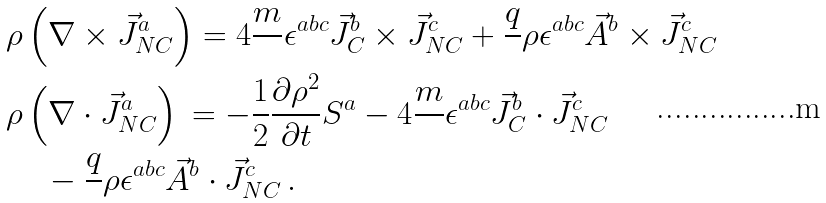<formula> <loc_0><loc_0><loc_500><loc_500>& \rho \left ( \nabla \times \vec { J } _ { N C } ^ { a } \right ) = 4 \frac { m } { } \epsilon ^ { a b c } \vec { J } _ { C } ^ { b } \times \vec { J } _ { N C } ^ { c } + \frac { q } { } \rho \epsilon ^ { a b c } \vec { A } ^ { b } \times \vec { J } _ { N C } ^ { c } \\ & \rho \left ( \nabla \cdot \vec { J } _ { N C } ^ { a } \right ) \, = - \frac { 1 } { 2 } \frac { \partial \rho ^ { 2 } } { \partial t } S ^ { a } - 4 \frac { m } { } \epsilon ^ { a b c } \vec { J } _ { C } ^ { b } \cdot \vec { J } _ { N C } ^ { c } \\ & \quad \, - \frac { q } { } \rho \epsilon ^ { a b c } \vec { A } ^ { b } \cdot \vec { J } _ { N C } ^ { c } \, .</formula> 